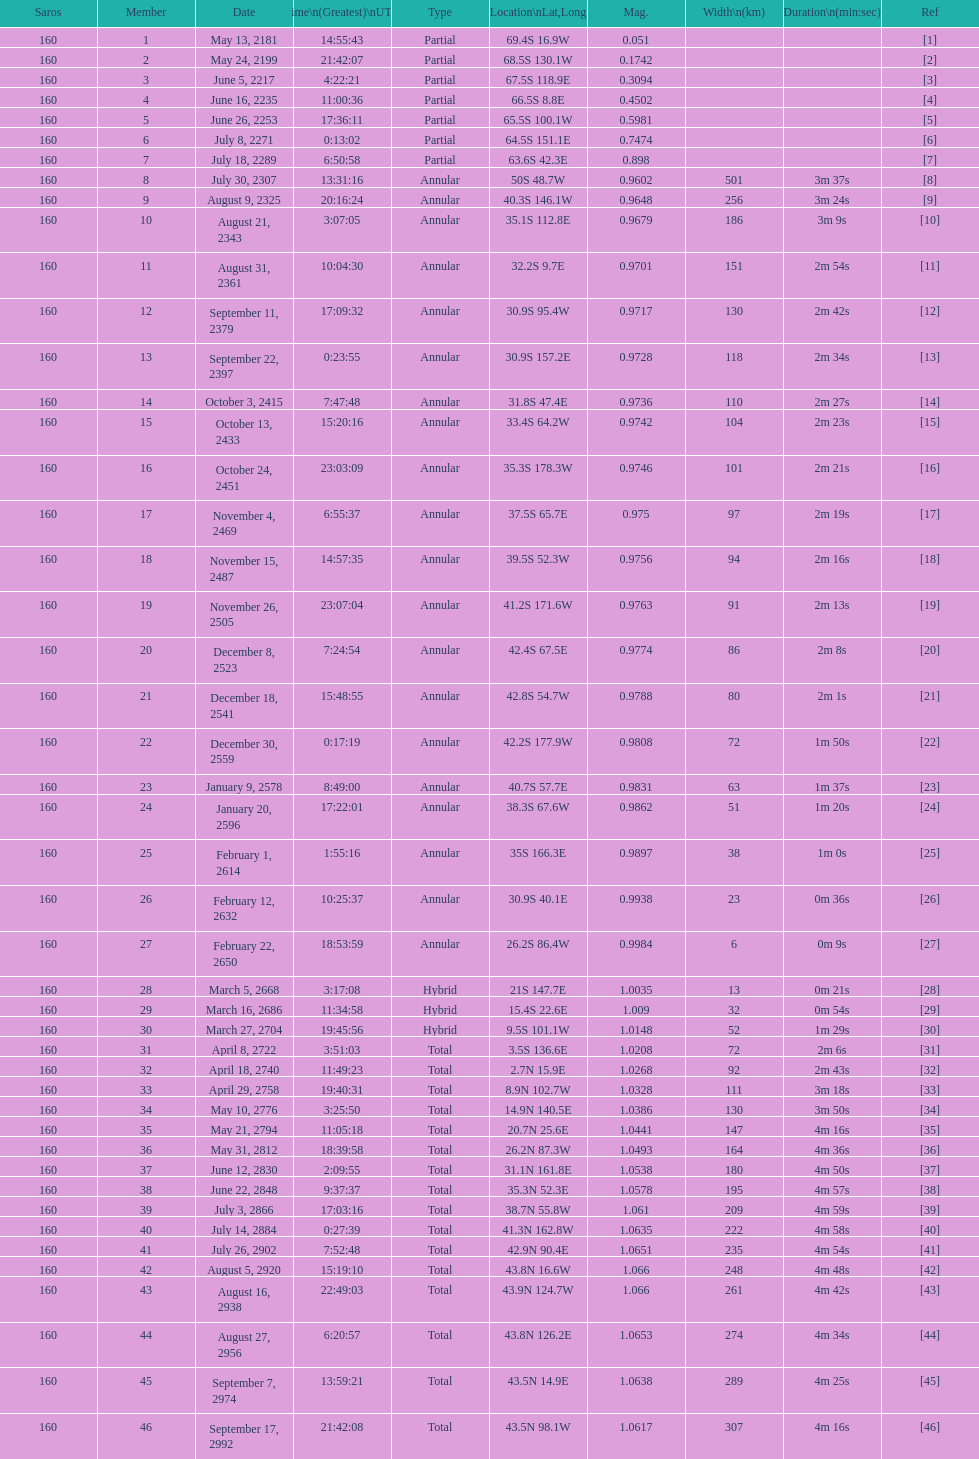After the solar saros on may 24, 2199, when can we expect the next one to occur? June 5, 2217. 